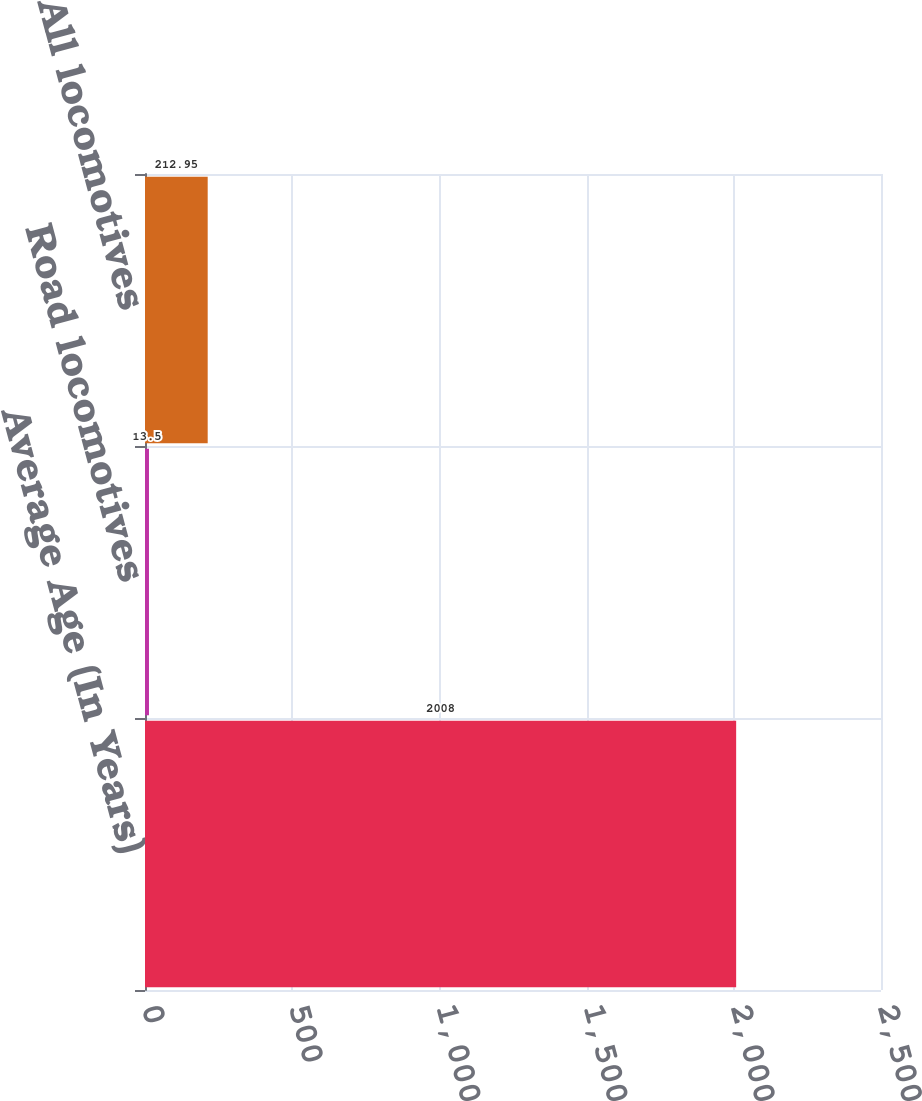Convert chart. <chart><loc_0><loc_0><loc_500><loc_500><bar_chart><fcel>Average Age (In Years)<fcel>Road locomotives<fcel>All locomotives<nl><fcel>2008<fcel>13.5<fcel>212.95<nl></chart> 